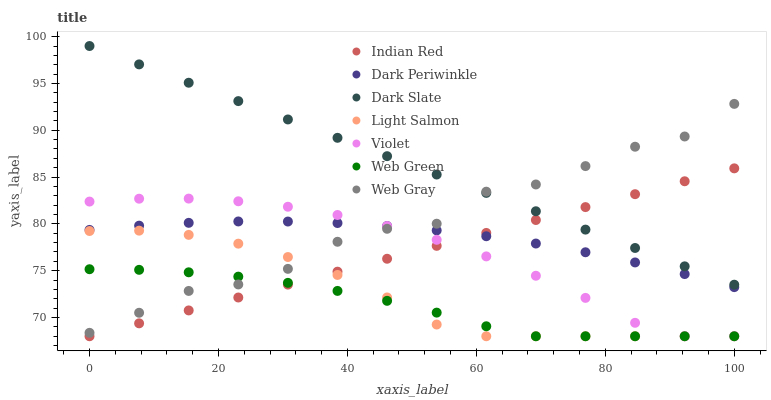Does Web Green have the minimum area under the curve?
Answer yes or no. Yes. Does Dark Slate have the maximum area under the curve?
Answer yes or no. Yes. Does Web Gray have the minimum area under the curve?
Answer yes or no. No. Does Web Gray have the maximum area under the curve?
Answer yes or no. No. Is Dark Slate the smoothest?
Answer yes or no. Yes. Is Web Gray the roughest?
Answer yes or no. Yes. Is Web Green the smoothest?
Answer yes or no. No. Is Web Green the roughest?
Answer yes or no. No. Does Light Salmon have the lowest value?
Answer yes or no. Yes. Does Web Gray have the lowest value?
Answer yes or no. No. Does Dark Slate have the highest value?
Answer yes or no. Yes. Does Web Gray have the highest value?
Answer yes or no. No. Is Dark Periwinkle less than Dark Slate?
Answer yes or no. Yes. Is Dark Slate greater than Web Green?
Answer yes or no. Yes. Does Web Gray intersect Violet?
Answer yes or no. Yes. Is Web Gray less than Violet?
Answer yes or no. No. Is Web Gray greater than Violet?
Answer yes or no. No. Does Dark Periwinkle intersect Dark Slate?
Answer yes or no. No. 